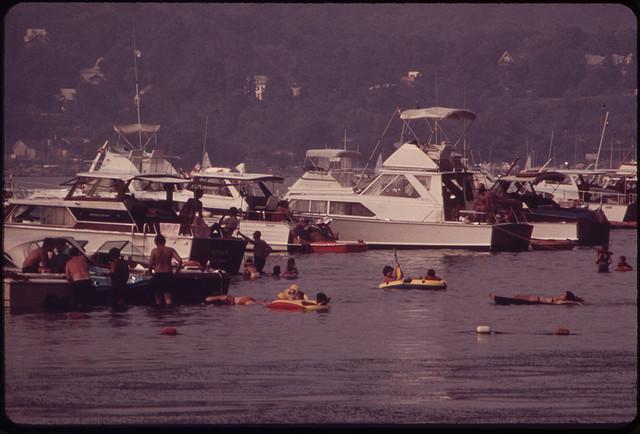How many boats are there?
Give a very brief answer. 6. How many train cars are painted black?
Give a very brief answer. 0. 